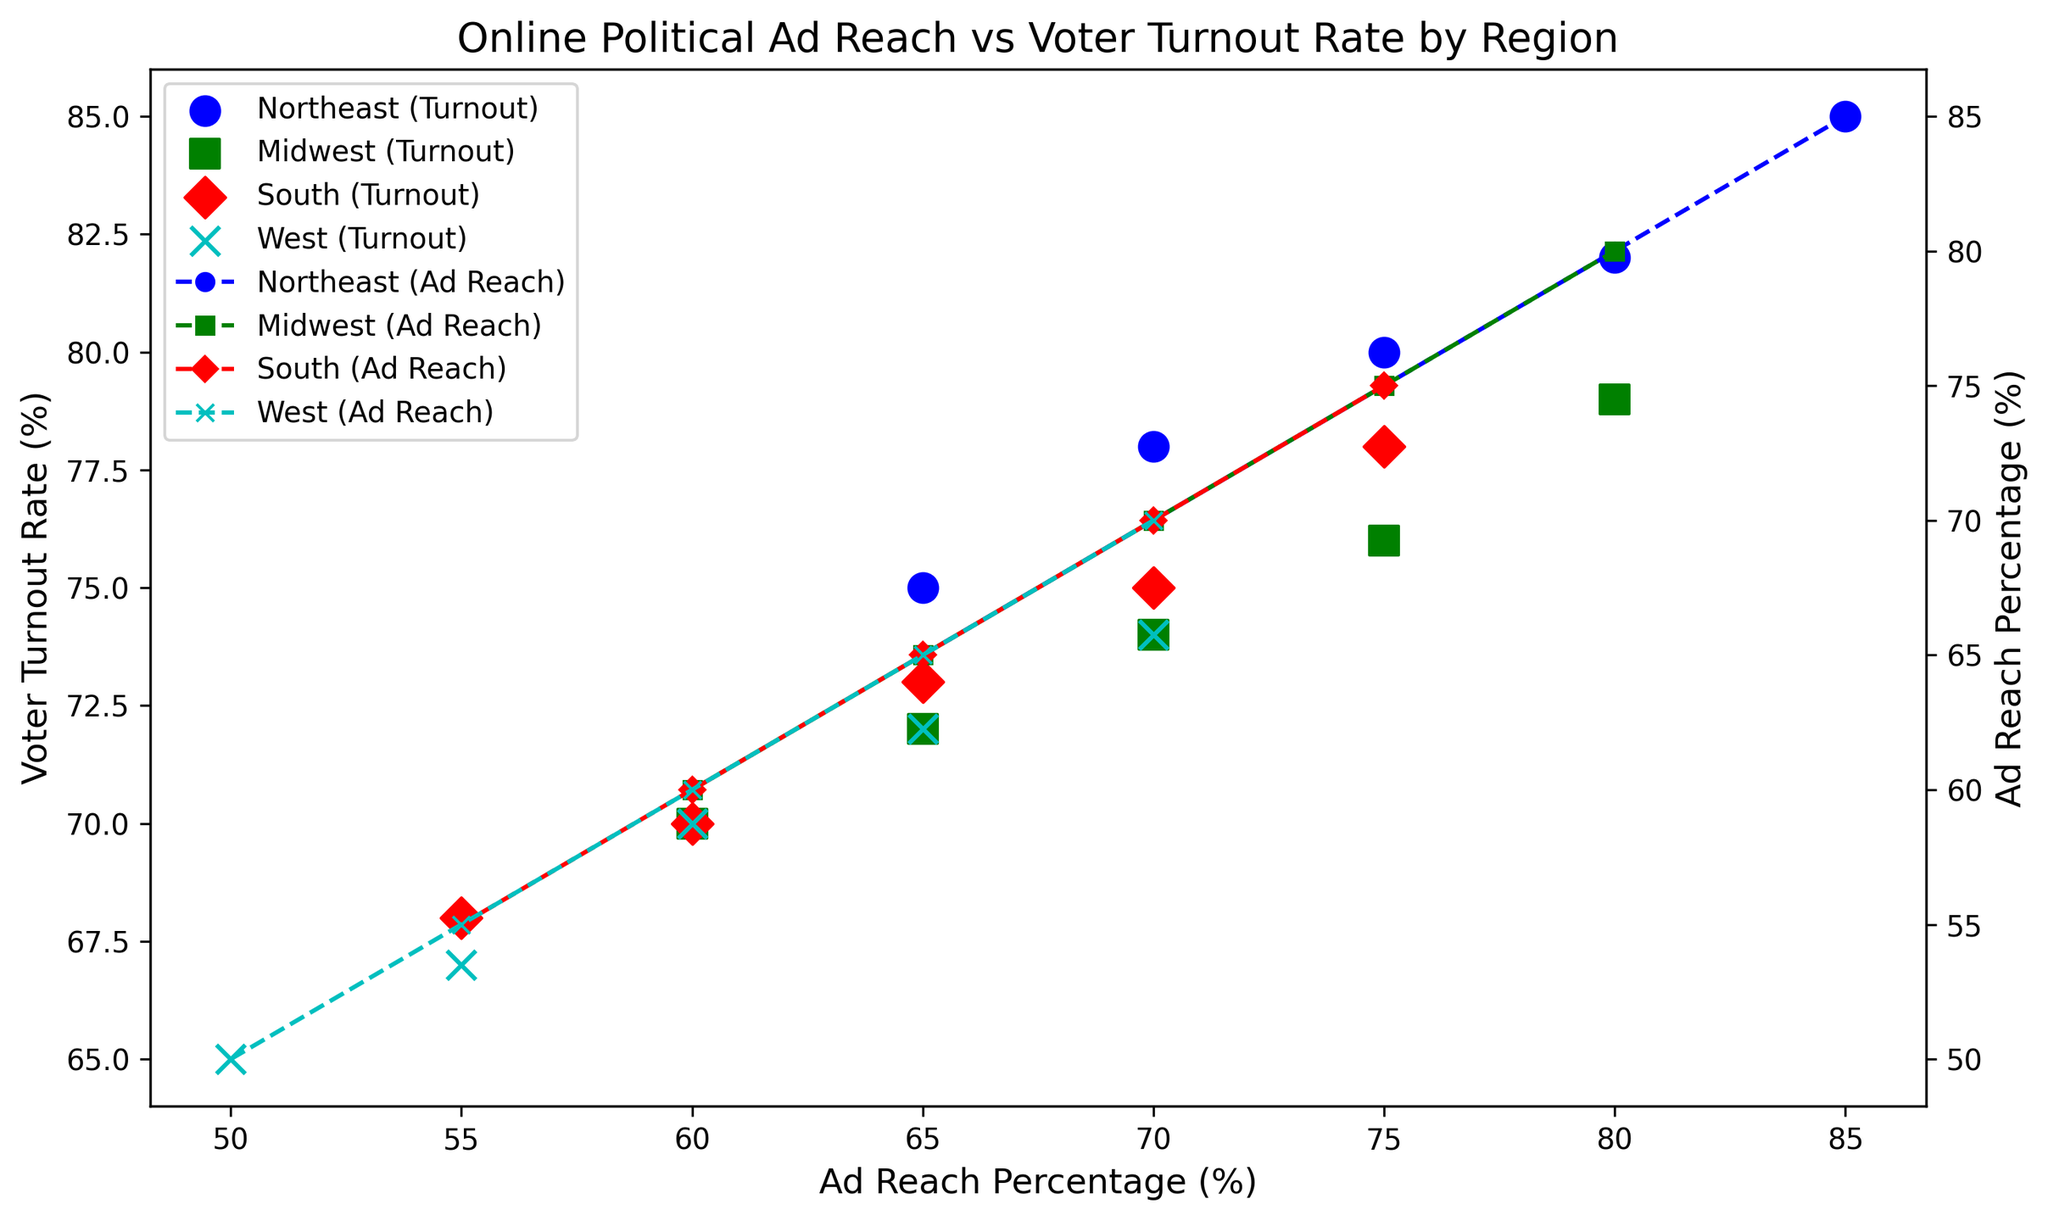What's the relationship between Ad Reach Percentage and Voter Turnout Rate for the Northeast region? Observing the scatter plot and line plot for the Northeast region (marked with o), it shows that as Ad Reach Percentage increases, the Voter Turnout Rate also increases.
Answer: Positive correlation Which region has the highest Voter Turnout Rate? By looking at the scatter plots for all the regions, the Northeast region, represented with circular markers (o), reaches the highest Voter Turnout Rate at 85%.
Answer: Northeast Among the regions plotted, which region exhibits the lowest initial Ad Reach Percentage? Reviewing the scatter plots, the West region starts with the lowest Ad Reach Percentage of 50%, shown by x markers.
Answer: West How does the Voter Turnout Rate compare between the South and Midwest regions when Ad Reach Percentage is at 70%? By checking the specific points where Ad Reach Percentage is 70%, the South region (triangle markers) has a Voter Turnout Rate of 75%, while the Midwest region (square markers) has a Voter Turnout Rate of 74%.
Answer: South What is the average Ad Reach Percentage for the South region? The data points for the South region are 55, 60, 65, 70, and 75. Adding these gives 325, dividing by 5 data points gives an average of 325/5 = 65.
Answer: 65 For the West region, which Ad Reach Percentage is associated with the highest Voter Turnout Rate? Observing the x markers for the West region on the scatter plot, the highest Voter Turnout Rate corresponds to an Ad Reach Percentage of 70.
Answer: 70 What is the difference in the highest Voter Turnout Rate between the Northeast and Midwest regions? The highest Voter Turnout Rate for the Northeast is 85%, and for the Midwest, it is 79%. The difference is 85 - 79 = 6.
Answer: 6 If we combine the initial Voter Turnout Rates for all regions, what do we get? The initial Voter Turnout Rates are: Northeast (75), Midwest (70), South (68), West (65). Summing these values gives 75 + 70 + 68 + 65 = 278.
Answer: 278 Which region shows the least increase in Voter Turnout Rate as Ad Reach Percentage increases from its lowest to highest value? By observing the scatter plots, we see that the West region (x markers) shows the smallest increase in Voter Turnout Rate from 65% to 74%, an increase of 9 percentage points.
Answer: West 